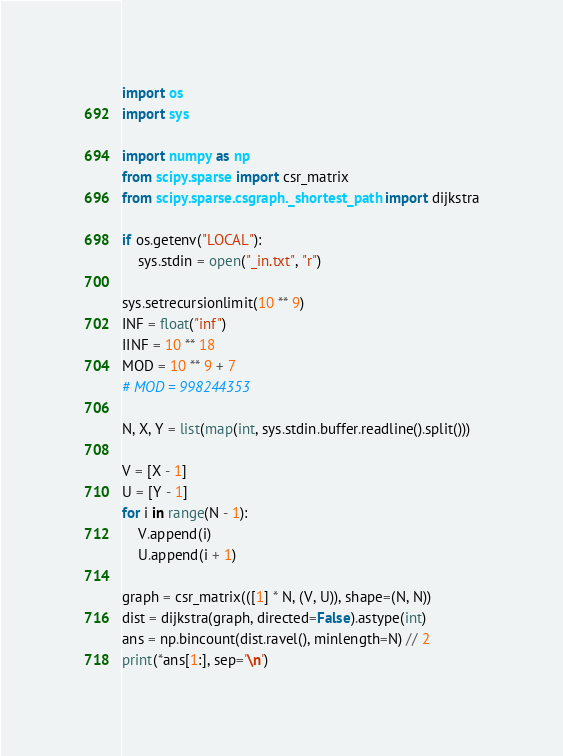Convert code to text. <code><loc_0><loc_0><loc_500><loc_500><_Python_>import os
import sys

import numpy as np
from scipy.sparse import csr_matrix
from scipy.sparse.csgraph._shortest_path import dijkstra

if os.getenv("LOCAL"):
    sys.stdin = open("_in.txt", "r")

sys.setrecursionlimit(10 ** 9)
INF = float("inf")
IINF = 10 ** 18
MOD = 10 ** 9 + 7
# MOD = 998244353

N, X, Y = list(map(int, sys.stdin.buffer.readline().split()))

V = [X - 1]
U = [Y - 1]
for i in range(N - 1):
    V.append(i)
    U.append(i + 1)

graph = csr_matrix(([1] * N, (V, U)), shape=(N, N))
dist = dijkstra(graph, directed=False).astype(int)
ans = np.bincount(dist.ravel(), minlength=N) // 2
print(*ans[1:], sep='\n')
</code> 